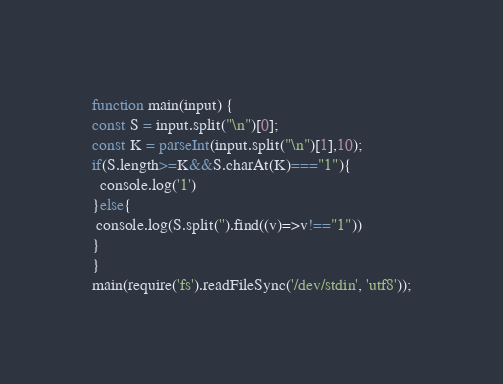<code> <loc_0><loc_0><loc_500><loc_500><_TypeScript_>function main(input) {
const S = input.split("\n")[0];
const K = parseInt(input.split("\n")[1],10);
if(S.length>=K&&S.charAt(K)==="1"){
  console.log('1')
}else{
 console.log(S.split('').find((v)=>v!=="1")) 
}
}
main(require('fs').readFileSync('/dev/stdin', 'utf8'));</code> 